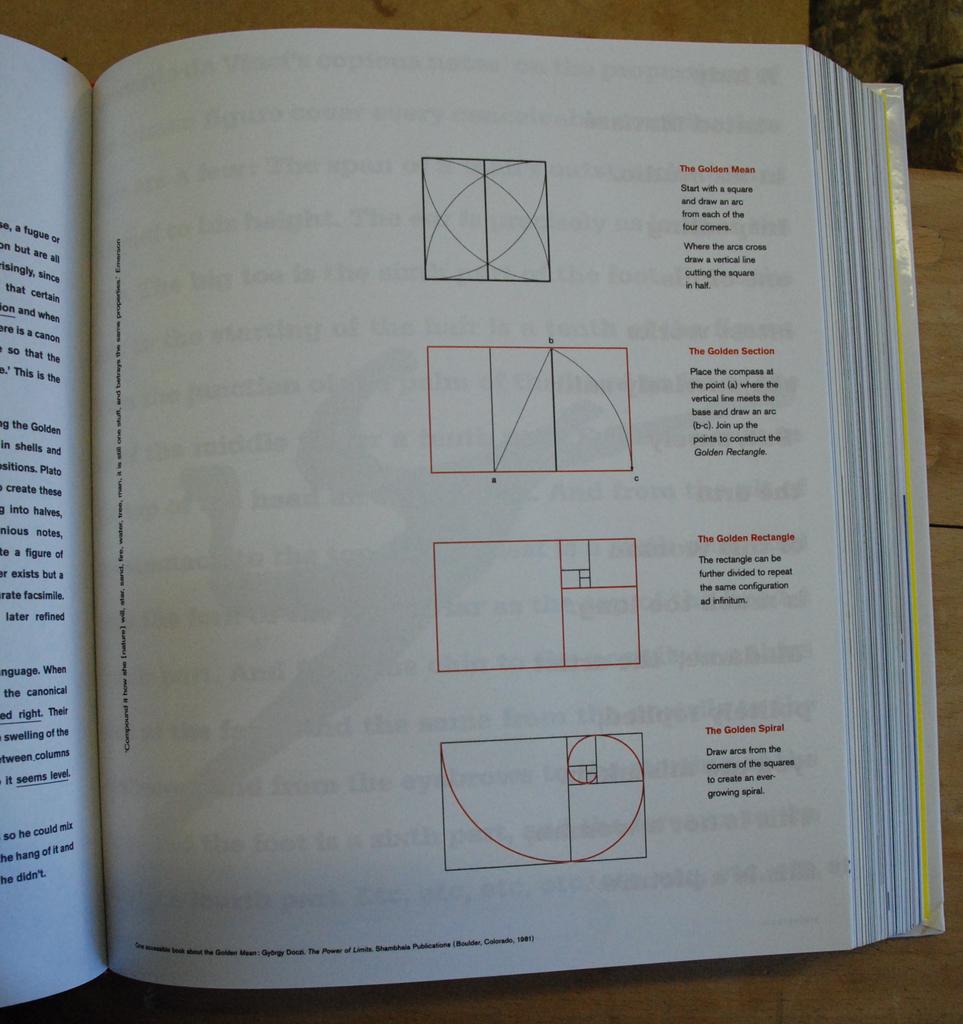What type of rectangle is shown second to last?
Keep it short and to the point. Golden. 